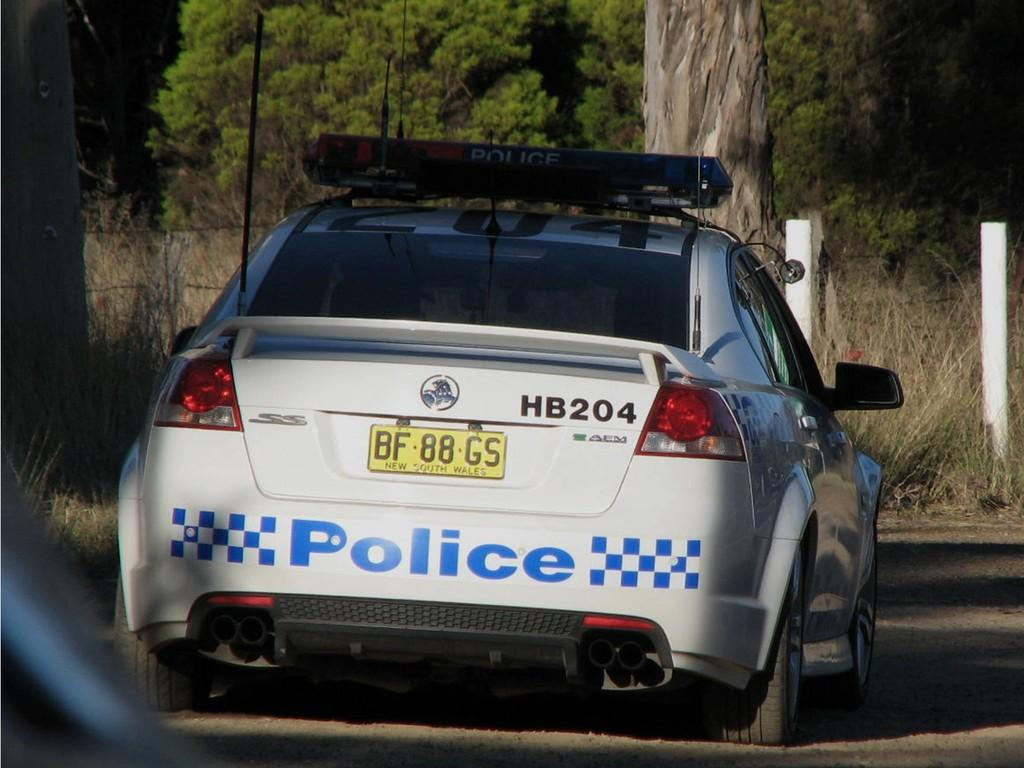<image>
Give a short and clear explanation of the subsequent image. Police car which says POLICE in blue on the back. 